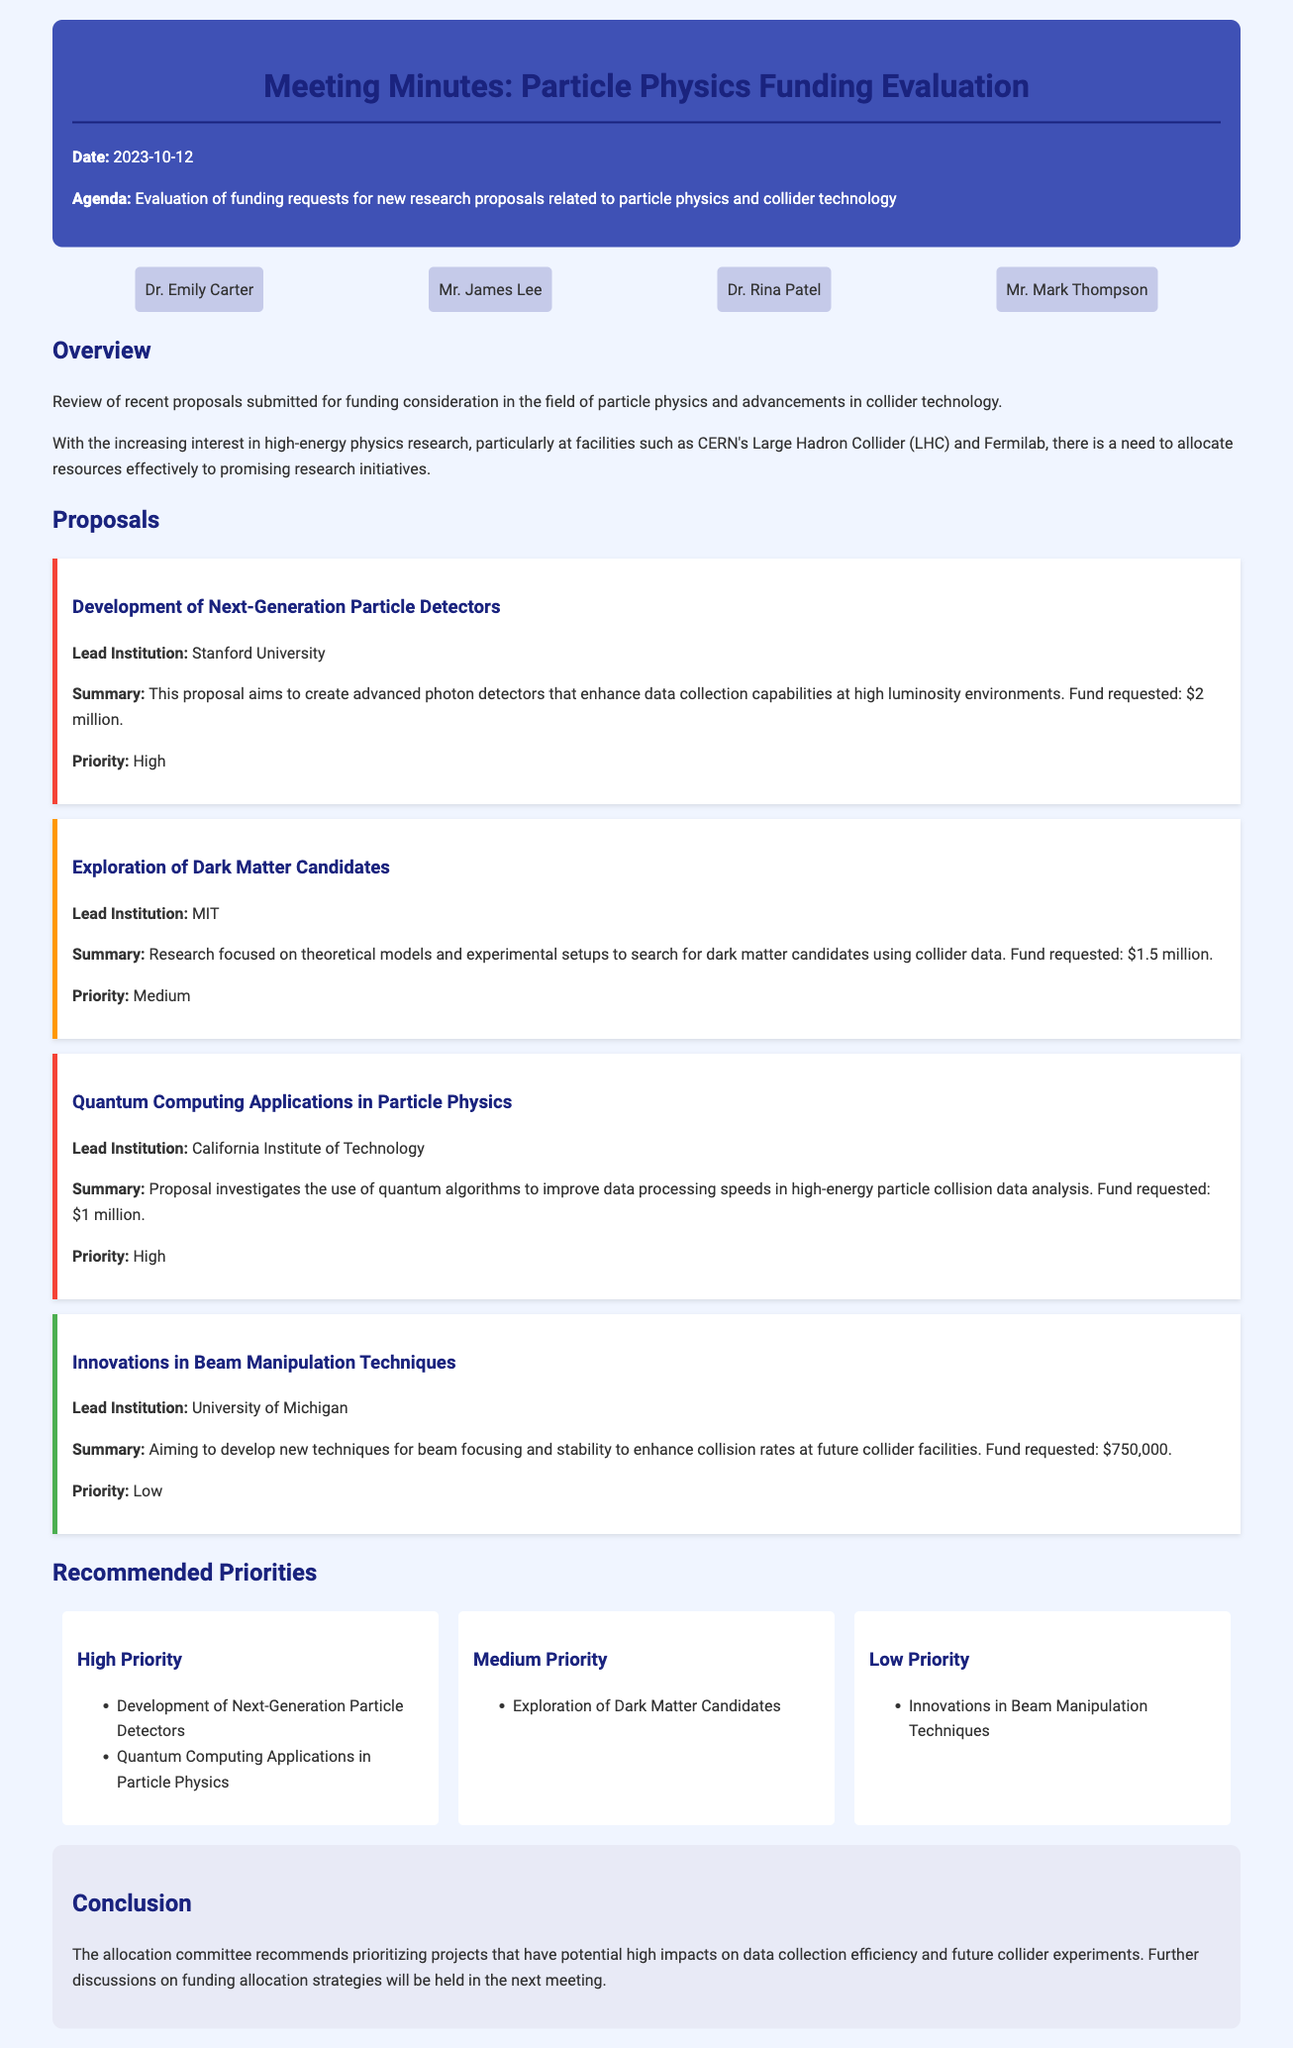what is the date of the meeting? The date of the meeting is mentioned at the beginning of the document.
Answer: 2023-10-12 who is the lead institution for the proposal on dark matter candidates? The lead institution is specified in the section discussing the proposal focused on dark matter candidates.
Answer: MIT how much funding is requested for the development of next-generation particle detectors? The funding requested is listed in the proposal for next-generation particle detectors.
Answer: $2 million which proposal has a medium priority? The document outlines proposals with different priority levels, and the one with medium priority is clearly mentioned.
Answer: Exploration of Dark Matter Candidates what are the two high-priority proposals? The high-priority proposals are listed under the recommended priorities section and require identification based on that information.
Answer: Development of Next-Generation Particle Detectors, Quantum Computing Applications in Particle Physics what is the total amount requested for the low priority proposal? The funding requested for the low priority proposal is specified, which is necessary for answering this question.
Answer: $750,000 what is the focus of the innovations in beam manipulation techniques proposal? The focus is described within the proposal itself, summarizing its main objective clearly.
Answer: Develop new techniques for beam focusing and stability who recommended prioritizing projects with high impacts on data collection efficiency? The conclusion section mentions who made the recommendations, which is essential for understanding the document's summary.
Answer: The allocation committee 